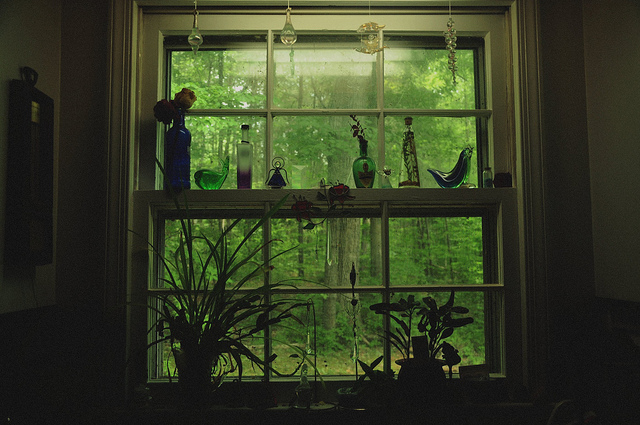What can you tell me about the plants in the image? In the bottom part of the image, we see a variety of healthy green plants. On the left side, there is a tall, leafy plant with thin stalks that seem to reach upward. Moving towards the center, there are a few smaller plants with broad leaves, possibly some indoor decorative plants that thrive in moderate sunlight. On the far right, a silhouette of another plant is visible, adding to the lush and serene ambiance created by the combination of greenery both inside and outside the window. 